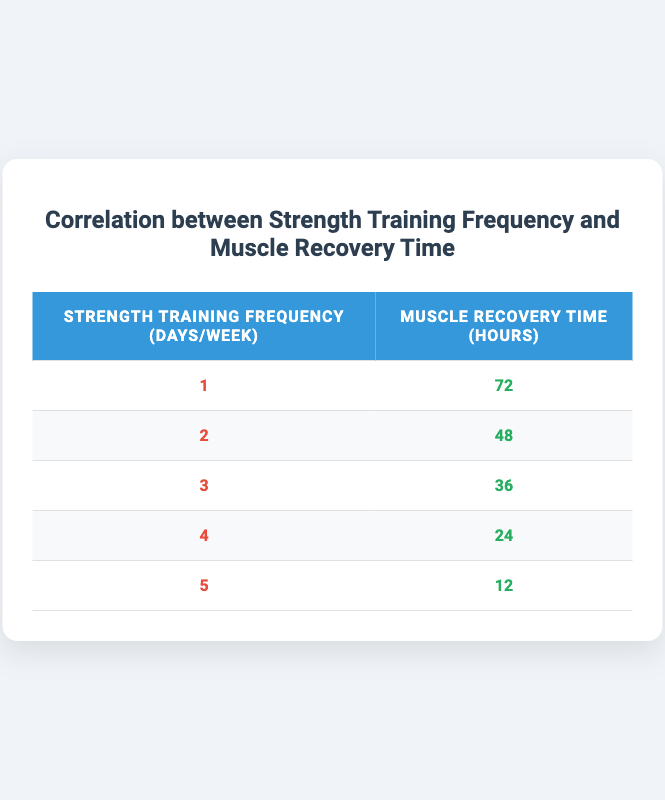What is the muscle recovery time after training 4 days a week? The table shows that the muscle recovery time for a frequency of 4 strength training days per week is 24 hours.
Answer: 24 hours How many hours of muscle recovery are needed for 2 days of strength training per week? According to the table, the muscle recovery time for training 2 days a week is 48 hours.
Answer: 48 hours Is it true that training 5 days a week leads to less recovery time compared to training 1 day a week? Yes, the table shows that muscle recovery time at 5 days a week is 12 hours, which is significantly less than the 72 hours required for 1 day a week.
Answer: Yes What is the average muscle recovery time across the frequencies listed in the table? To find the average, first sum the recovery times: 72 + 48 + 36 + 24 + 12 = 192. There are 5 entries, so the average is 192 / 5 = 38.4 hours.
Answer: 38.4 hours How does the muscle recovery time change as strength training frequency increases from 1 to 5 days a week? Observing the table, as strength training frequency increases from 1 to 5 days per week, recovery time decreases from 72 hours to 12 hours, indicating an inverse relationship.
Answer: Decreases from 72 to 12 hours What is the difference in muscle recovery time between training 3 days and training 1 day a week? The muscle recovery time for 3 days is 36 hours and for 1 day is 72 hours. The difference is 72 - 36 = 36 hours.
Answer: 36 hours Does training 3 times a week require less recovery time than training 2 times a week? Yes, the recovery time for training 3 days a week is 36 hours, which is less than 48 hours for training 2 days a week, confirming this statement.
Answer: Yes What total muscle recovery time is observed when aggregating the recovery times from all training frequencies? To find the total, sum all recovery times: 72 + 48 + 36 + 24 + 12 = 192 hours, which provides the total recovery time observed.
Answer: 192 hours 